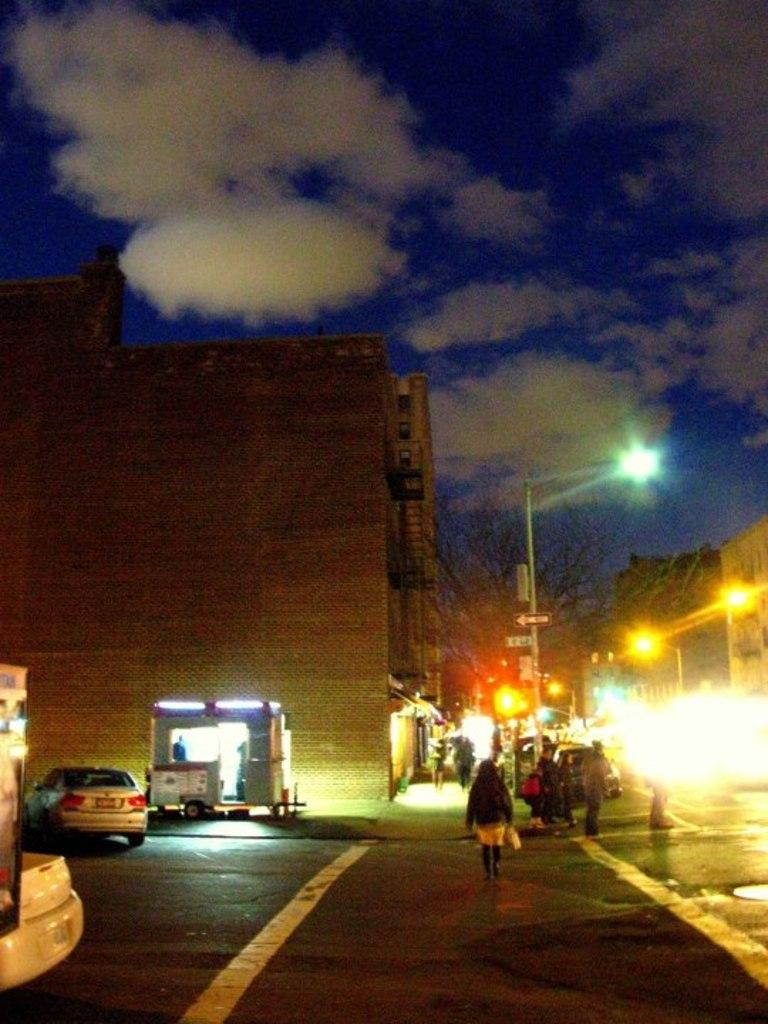What can be seen on the road in the image? There are vehicles on the road in the image. What structures are visible in the image? There are buildings, a tree, light poles, and signboards in the image. Are there any people present in the image? Yes, there are people in the image. What is the condition of the sky in the image? The sky is cloudy in the image. Can you tell me how many times the grandmother appears in the image? There is no mention of a grandmother in the image, so it is not possible to answer that question. What type of brake system is installed on the vehicles in the image? The image does not provide enough detail to determine the type of brake system on the vehicles. 